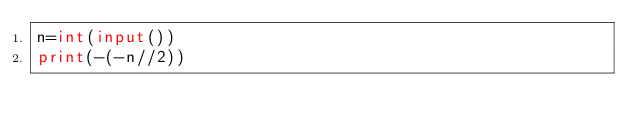<code> <loc_0><loc_0><loc_500><loc_500><_Python_>n=int(input())
print(-(-n//2))</code> 